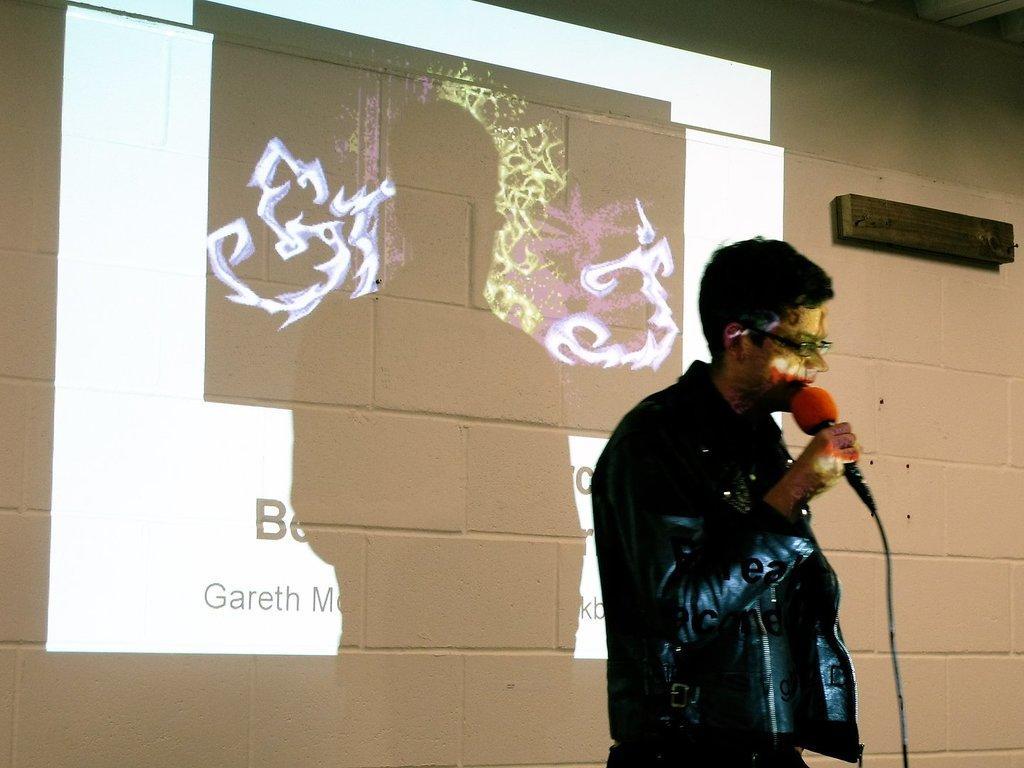How would you summarize this image in a sentence or two? In this image we can see a person and a microphone. In the background of the image there is a wall, projector screen and an object. 